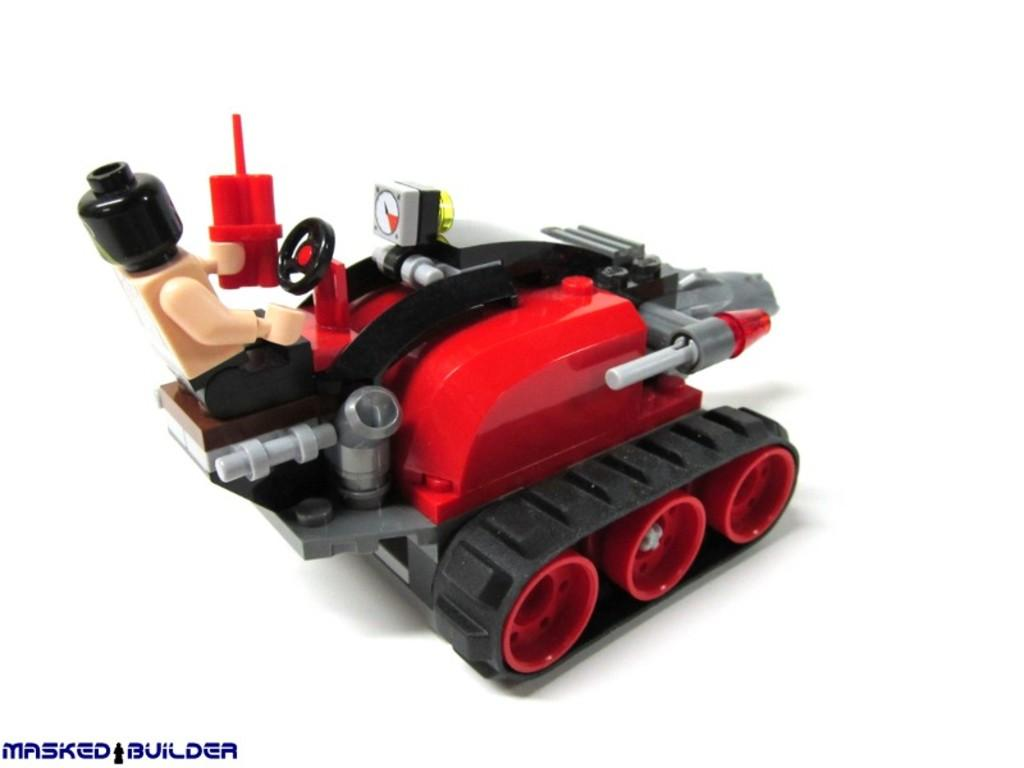What is the main object in the image? There is a toy in the image. Where is the toy located? The toy is on an object. Can you describe any additional features of the image? There is a watermark on the image. What type of calendar is hanging on the wall in the image? There is no calendar present in the image; it only features a toy on an object and a watermark. Can you see any jellyfish swimming in the image? There are no jellyfish present in the image. 